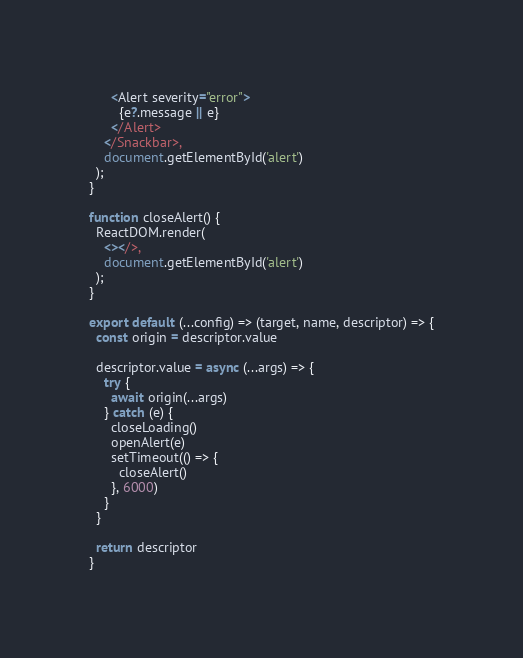Convert code to text. <code><loc_0><loc_0><loc_500><loc_500><_JavaScript_>      <Alert severity="error">
        {e?.message || e}
      </Alert>
    </Snackbar>,
    document.getElementById('alert')
  );
}

function closeAlert() {
  ReactDOM.render(
    <></>,
    document.getElementById('alert')
  );
}

export default (...config) => (target, name, descriptor) => {
  const origin = descriptor.value

  descriptor.value = async (...args) => {
    try {
      await origin(...args)
    } catch (e) {
      closeLoading()
      openAlert(e)
      setTimeout(() => {
        closeAlert()
      }, 6000)
    }
  }

  return descriptor
}</code> 